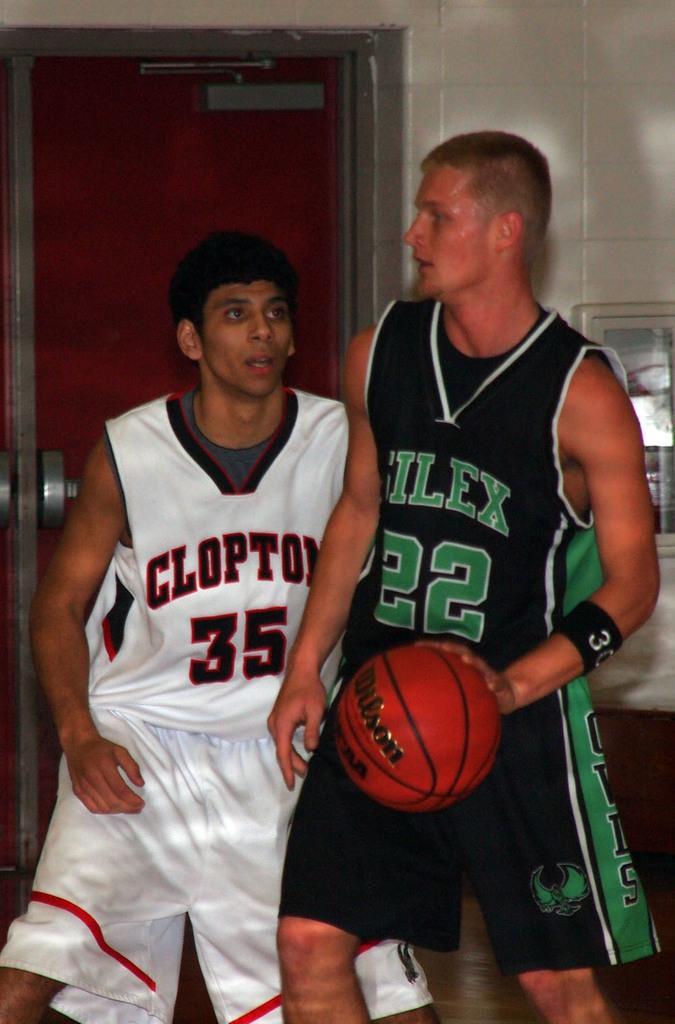Could you give a brief overview of what you see in this image? In this image I can see two persons, the person at right wearing black and green dress and the person at left wearing white dress, I can also see a ball. At the background the wall is in white color. 